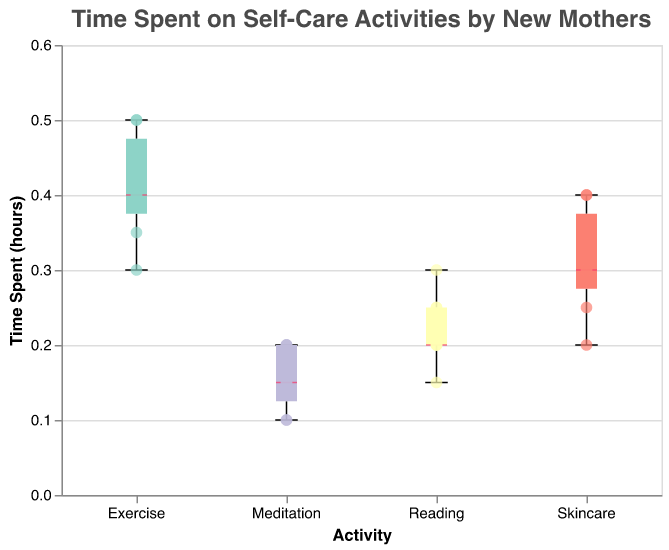What is the title of the plot? The title of the plot is usually displayed at the top and is a textual descriptor that summarizes what the plot is about. The title here says "Time Spent on Self-Care Activities by New Mothers," indicating that the plot shows data on how much time new mothers spend on self-care activities.
Answer: Time Spent on Self-Care Activities by New Mothers What are the self-care activities listed on the x-axis? The x-axis usually lists the categorical variables. Here, it shows the different self-care activities that new mothers engage in, which are represented in the plot.
Answer: Exercise, Reading, Meditation, Skincare Which activity had the most consistent time spent on it? To determine consistency, we look at the spread of the data points (how close they are to each other). The more consistent an activity, the narrower the boxplot and fewer outliers. Here, Meditation has the most consistent time spent on it as its boxplot has the smallest range.
Answer: Meditation What is the median time spent on Exercise? The median of a box plot is shown with a line within the box. For Exercise, this line appears at the 0.4-hours mark.
Answer: 0.4 hours Which self-care activity has the highest outlier and what is its value? Outliers are points that fall outside the typical range of data in a box plot. For Exercise, there's a point above the maximum range of the box plot, shown near 0.5 hours.
Answer: Exercise, 0.5 hours Which activity shows the largest interquartile range (IQR)? The IQR is the range between the first quartile (25th percentile) and the third quartile (75th percentile) of the data. It is represented by the box in a box plot. Exercise has the largest spread between its quartiles.
Answer: Exercise How much time did new mothers spend on Reading on Day 5? Each scatter point signifies the time spent on an activity each day. Hovering over or closely examining these points linked to days shows that on Day 5, the time spent on Reading is marked at 0.3 hours.
Answer: 0.3 hours Compare the median time spent on Skincare to Meditation. The median is the line inside the box plot. The median for Skincare is around 0.3 hours, whereas, for Meditation, it is around 0.15 hours, indicating that the median time spent on Skincare is higher than on Meditation.
Answer: Skincare > Meditation On what days was the time spent on Meditation the same? By checking the scatter points for Meditation, we can see that the time spent on some days matches. Days 1 and 7 each have 0.15 hours marked for Meditation.
Answer: Day 1 and Day 7 